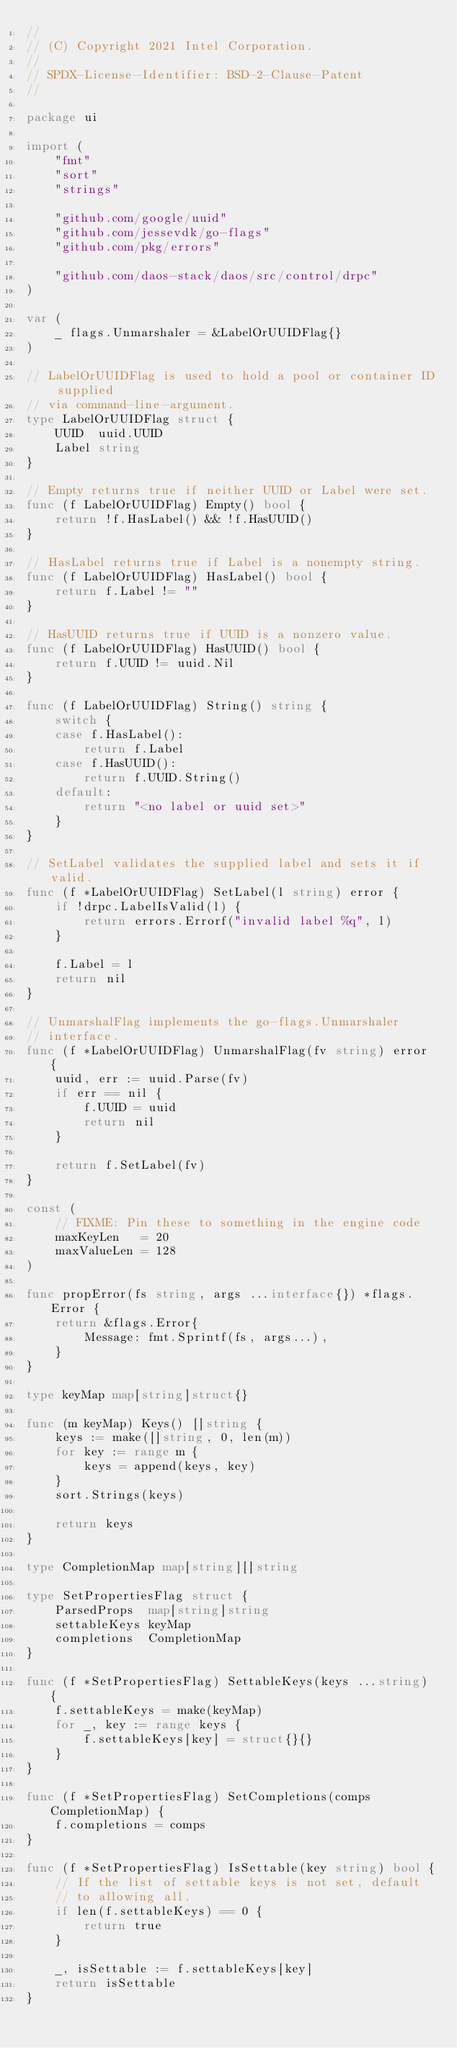Convert code to text. <code><loc_0><loc_0><loc_500><loc_500><_Go_>//
// (C) Copyright 2021 Intel Corporation.
//
// SPDX-License-Identifier: BSD-2-Clause-Patent
//

package ui

import (
	"fmt"
	"sort"
	"strings"

	"github.com/google/uuid"
	"github.com/jessevdk/go-flags"
	"github.com/pkg/errors"

	"github.com/daos-stack/daos/src/control/drpc"
)

var (
	_ flags.Unmarshaler = &LabelOrUUIDFlag{}
)

// LabelOrUUIDFlag is used to hold a pool or container ID supplied
// via command-line-argument.
type LabelOrUUIDFlag struct {
	UUID  uuid.UUID
	Label string
}

// Empty returns true if neither UUID or Label were set.
func (f LabelOrUUIDFlag) Empty() bool {
	return !f.HasLabel() && !f.HasUUID()
}

// HasLabel returns true if Label is a nonempty string.
func (f LabelOrUUIDFlag) HasLabel() bool {
	return f.Label != ""
}

// HasUUID returns true if UUID is a nonzero value.
func (f LabelOrUUIDFlag) HasUUID() bool {
	return f.UUID != uuid.Nil
}

func (f LabelOrUUIDFlag) String() string {
	switch {
	case f.HasLabel():
		return f.Label
	case f.HasUUID():
		return f.UUID.String()
	default:
		return "<no label or uuid set>"
	}
}

// SetLabel validates the supplied label and sets it if valid.
func (f *LabelOrUUIDFlag) SetLabel(l string) error {
	if !drpc.LabelIsValid(l) {
		return errors.Errorf("invalid label %q", l)
	}

	f.Label = l
	return nil
}

// UnmarshalFlag implements the go-flags.Unmarshaler
// interface.
func (f *LabelOrUUIDFlag) UnmarshalFlag(fv string) error {
	uuid, err := uuid.Parse(fv)
	if err == nil {
		f.UUID = uuid
		return nil
	}

	return f.SetLabel(fv)
}

const (
	// FIXME: Pin these to something in the engine code
	maxKeyLen   = 20
	maxValueLen = 128
)

func propError(fs string, args ...interface{}) *flags.Error {
	return &flags.Error{
		Message: fmt.Sprintf(fs, args...),
	}
}

type keyMap map[string]struct{}

func (m keyMap) Keys() []string {
	keys := make([]string, 0, len(m))
	for key := range m {
		keys = append(keys, key)
	}
	sort.Strings(keys)

	return keys
}

type CompletionMap map[string][]string

type SetPropertiesFlag struct {
	ParsedProps  map[string]string
	settableKeys keyMap
	completions  CompletionMap
}

func (f *SetPropertiesFlag) SettableKeys(keys ...string) {
	f.settableKeys = make(keyMap)
	for _, key := range keys {
		f.settableKeys[key] = struct{}{}
	}
}

func (f *SetPropertiesFlag) SetCompletions(comps CompletionMap) {
	f.completions = comps
}

func (f *SetPropertiesFlag) IsSettable(key string) bool {
	// If the list of settable keys is not set, default
	// to allowing all.
	if len(f.settableKeys) == 0 {
		return true
	}

	_, isSettable := f.settableKeys[key]
	return isSettable
}
</code> 